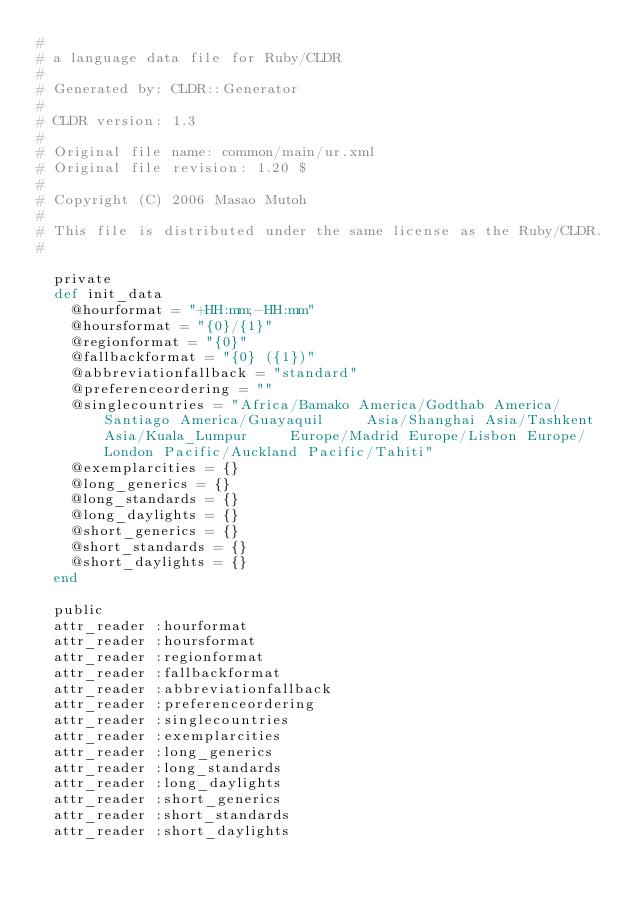<code> <loc_0><loc_0><loc_500><loc_500><_Ruby_>#
# a language data file for Ruby/CLDR
#
# Generated by: CLDR::Generator
#
# CLDR version: 1.3
#
# Original file name: common/main/ur.xml
# Original file revision: 1.20 $
#
# Copyright (C) 2006 Masao Mutoh
#
# This file is distributed under the same license as the Ruby/CLDR.
#

  private
  def init_data
    @hourformat = "+HH:mm;-HH:mm"
    @hoursformat = "{0}/{1}"
    @regionformat = "{0}"
    @fallbackformat = "{0} ({1})"
    @abbreviationfallback = "standard"
    @preferenceordering = ""
    @singlecountries = "Africa/Bamako America/Godthab America/Santiago America/Guayaquil     Asia/Shanghai Asia/Tashkent Asia/Kuala_Lumpur     Europe/Madrid Europe/Lisbon Europe/London Pacific/Auckland Pacific/Tahiti"
    @exemplarcities = {}
    @long_generics = {}
    @long_standards = {}
    @long_daylights = {}
    @short_generics = {}
    @short_standards = {}
    @short_daylights = {}
  end

  public
  attr_reader :hourformat
  attr_reader :hoursformat
  attr_reader :regionformat
  attr_reader :fallbackformat
  attr_reader :abbreviationfallback
  attr_reader :preferenceordering
  attr_reader :singlecountries
  attr_reader :exemplarcities
  attr_reader :long_generics
  attr_reader :long_standards
  attr_reader :long_daylights
  attr_reader :short_generics
  attr_reader :short_standards
  attr_reader :short_daylights
</code> 